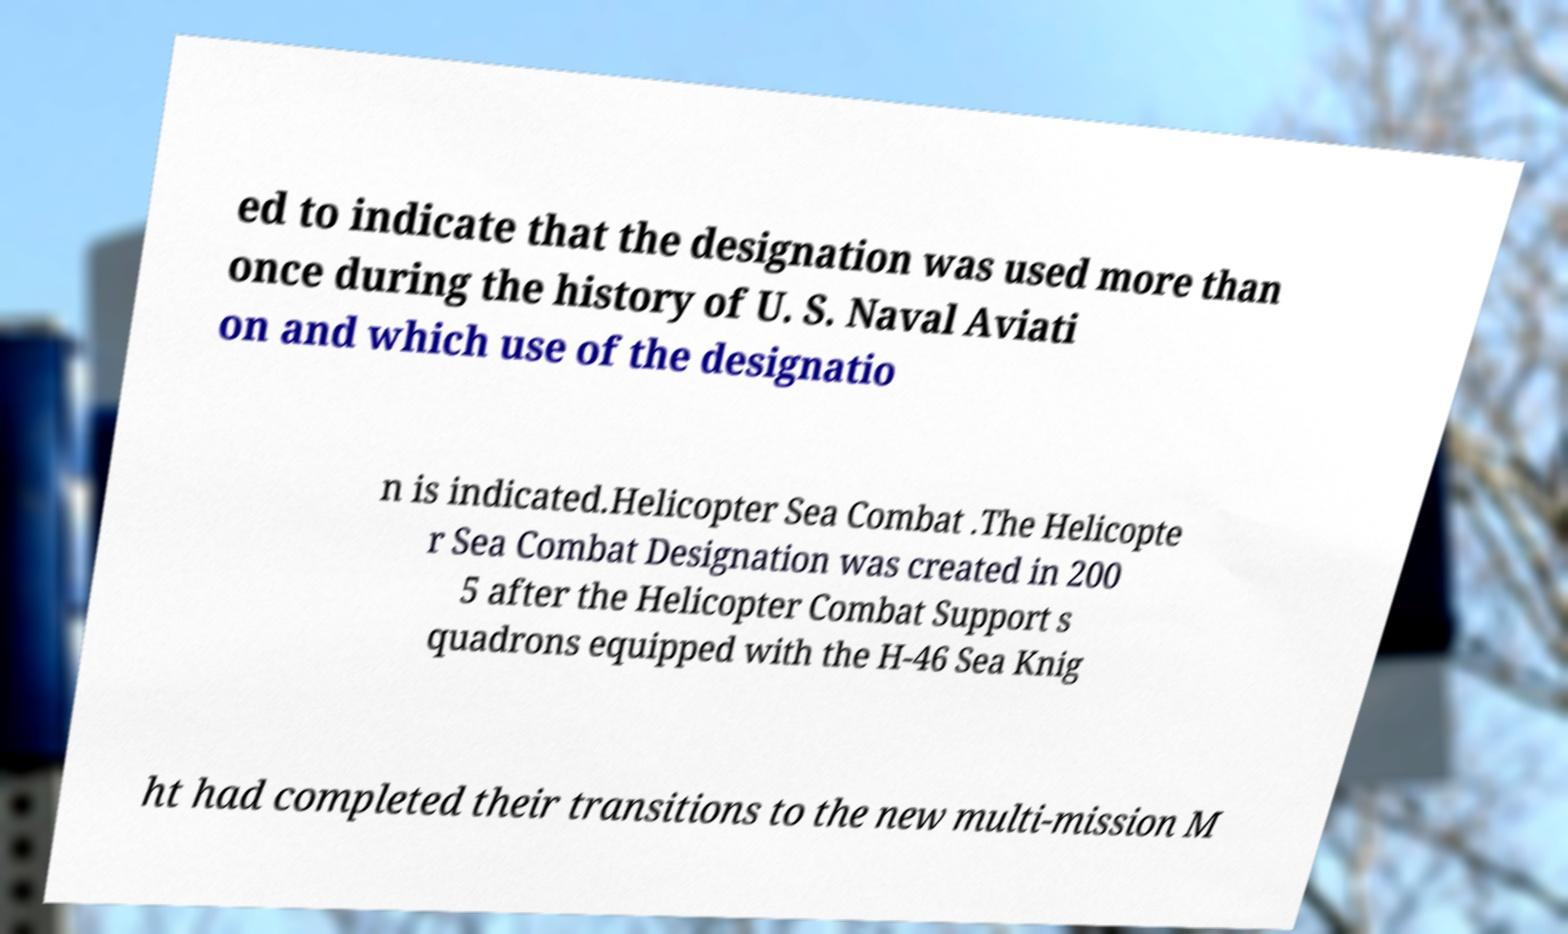Could you assist in decoding the text presented in this image and type it out clearly? ed to indicate that the designation was used more than once during the history of U. S. Naval Aviati on and which use of the designatio n is indicated.Helicopter Sea Combat .The Helicopte r Sea Combat Designation was created in 200 5 after the Helicopter Combat Support s quadrons equipped with the H-46 Sea Knig ht had completed their transitions to the new multi-mission M 